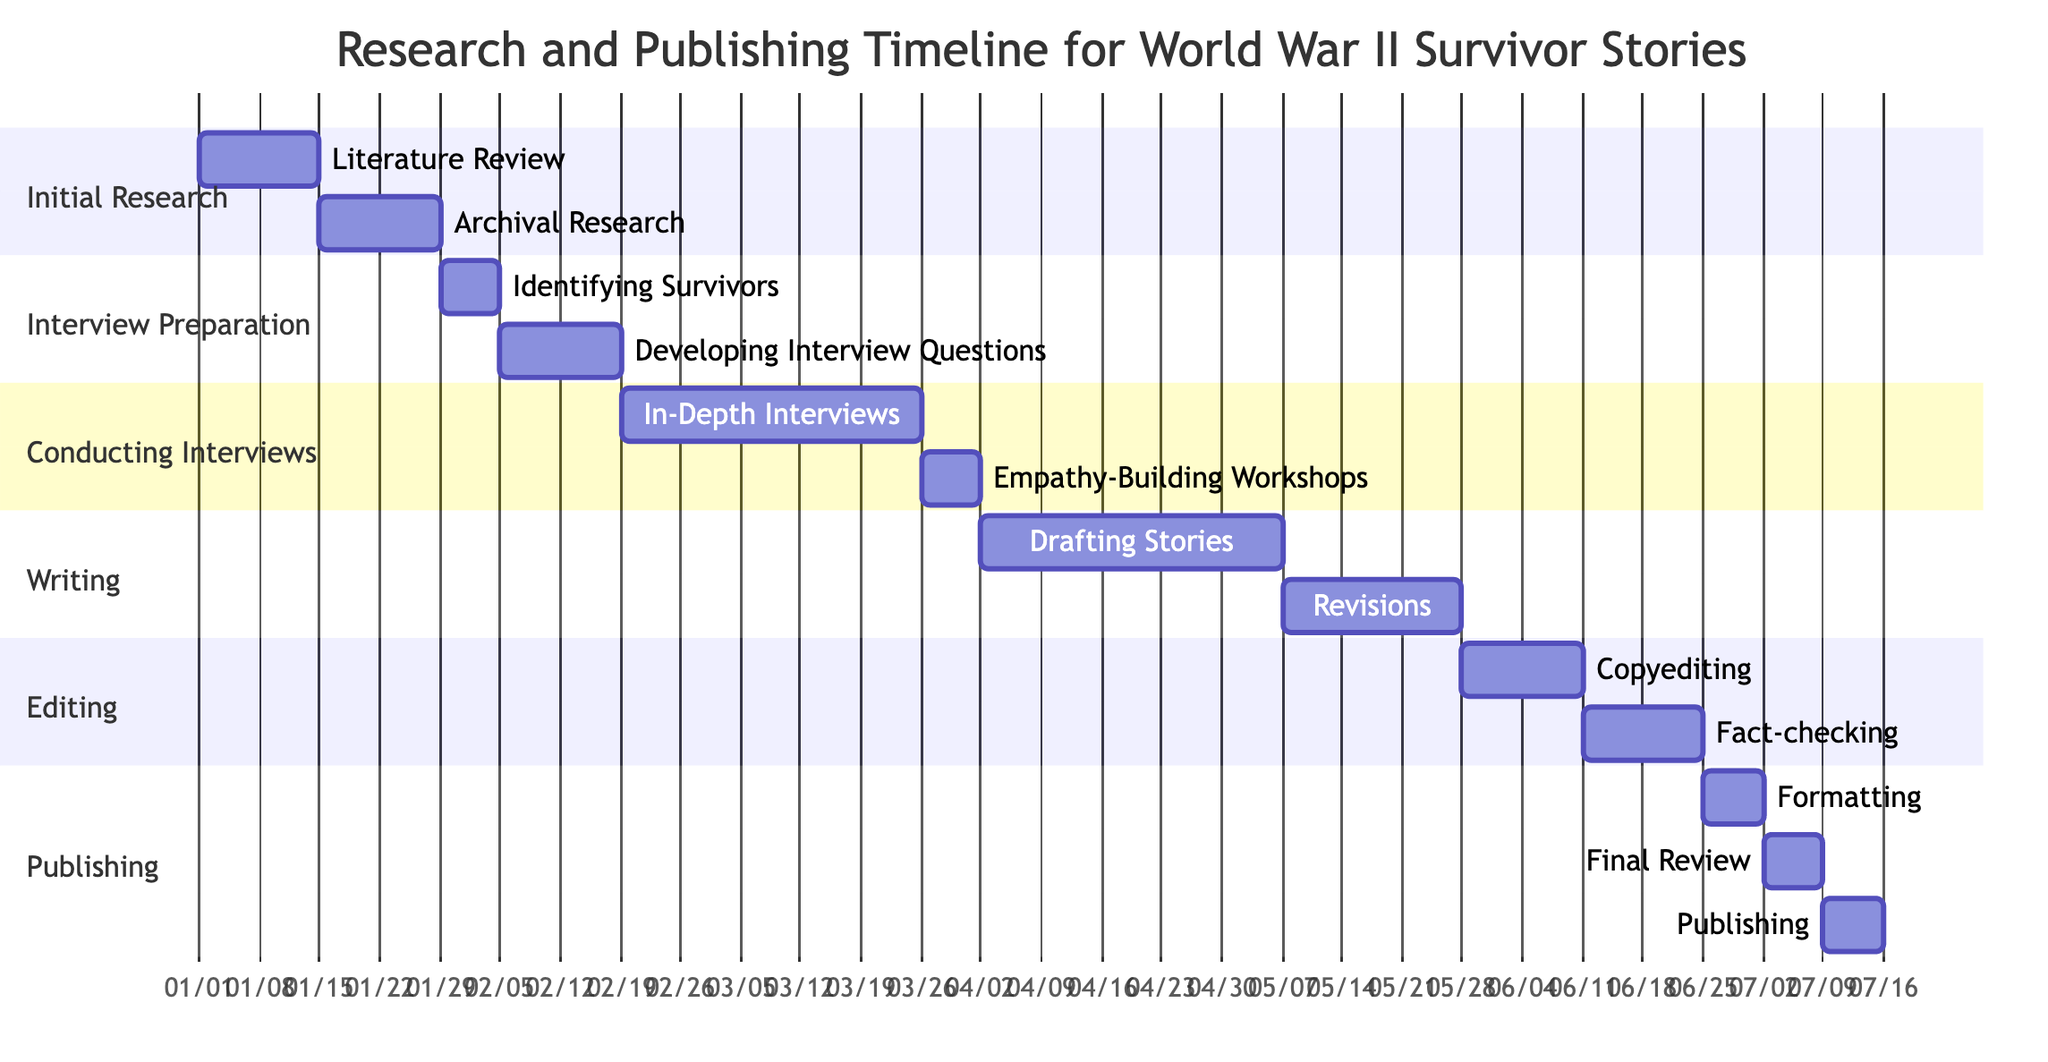What is the total duration for the "Conducting Interviews" phase? The "Conducting Interviews" phase encompasses two tasks: "In-Depth Interviews" for 5 weeks and "Empathy-Building Workshops" for 1 week. Adding them together gives a total of 5 + 1 = 6 weeks for this phase.
Answer: 6 weeks What task follows "Identifying Survivors"? In the Gantt chart, after "Identifying Survivors," the next task listed is "Developing Interview Questions." This can be found in the same section where the tasks are organized chronologically.
Answer: Developing Interview Questions Which phase has the shortest duration? Analyzing all phases, "Publishing" has the shortest duration of 3 weeks, consisting of three tasks, each taking 1 week. This makes it shorter than any other phases, which last longer.
Answer: 3 weeks How many tasks are there in the "Writing" phase? The "Writing" phase contains two distinct tasks: "Drafting Stories" and "Revisions." Therefore, by counting these tasks, we find there are a total of 2 tasks in this phase.
Answer: 2 tasks What is the duration of the "Empathy-Building Workshops"? The "Empathy-Building Workshops" is a single task with a specified duration of 1 week. This information can be found directly associated with its title in the "Conducting Interviews" phase.
Answer: 1 week How many total weeks does the entire research and publishing timeline last? To find the total duration, we must sum up the durations of all phases: 4 (Initial Research) + 3 (Interview Preparation) + 6 (Conducting Interviews) + 8 (Writing) + 4 (Editing) + 3 (Publishing) = 28 weeks in total.
Answer: 28 weeks 